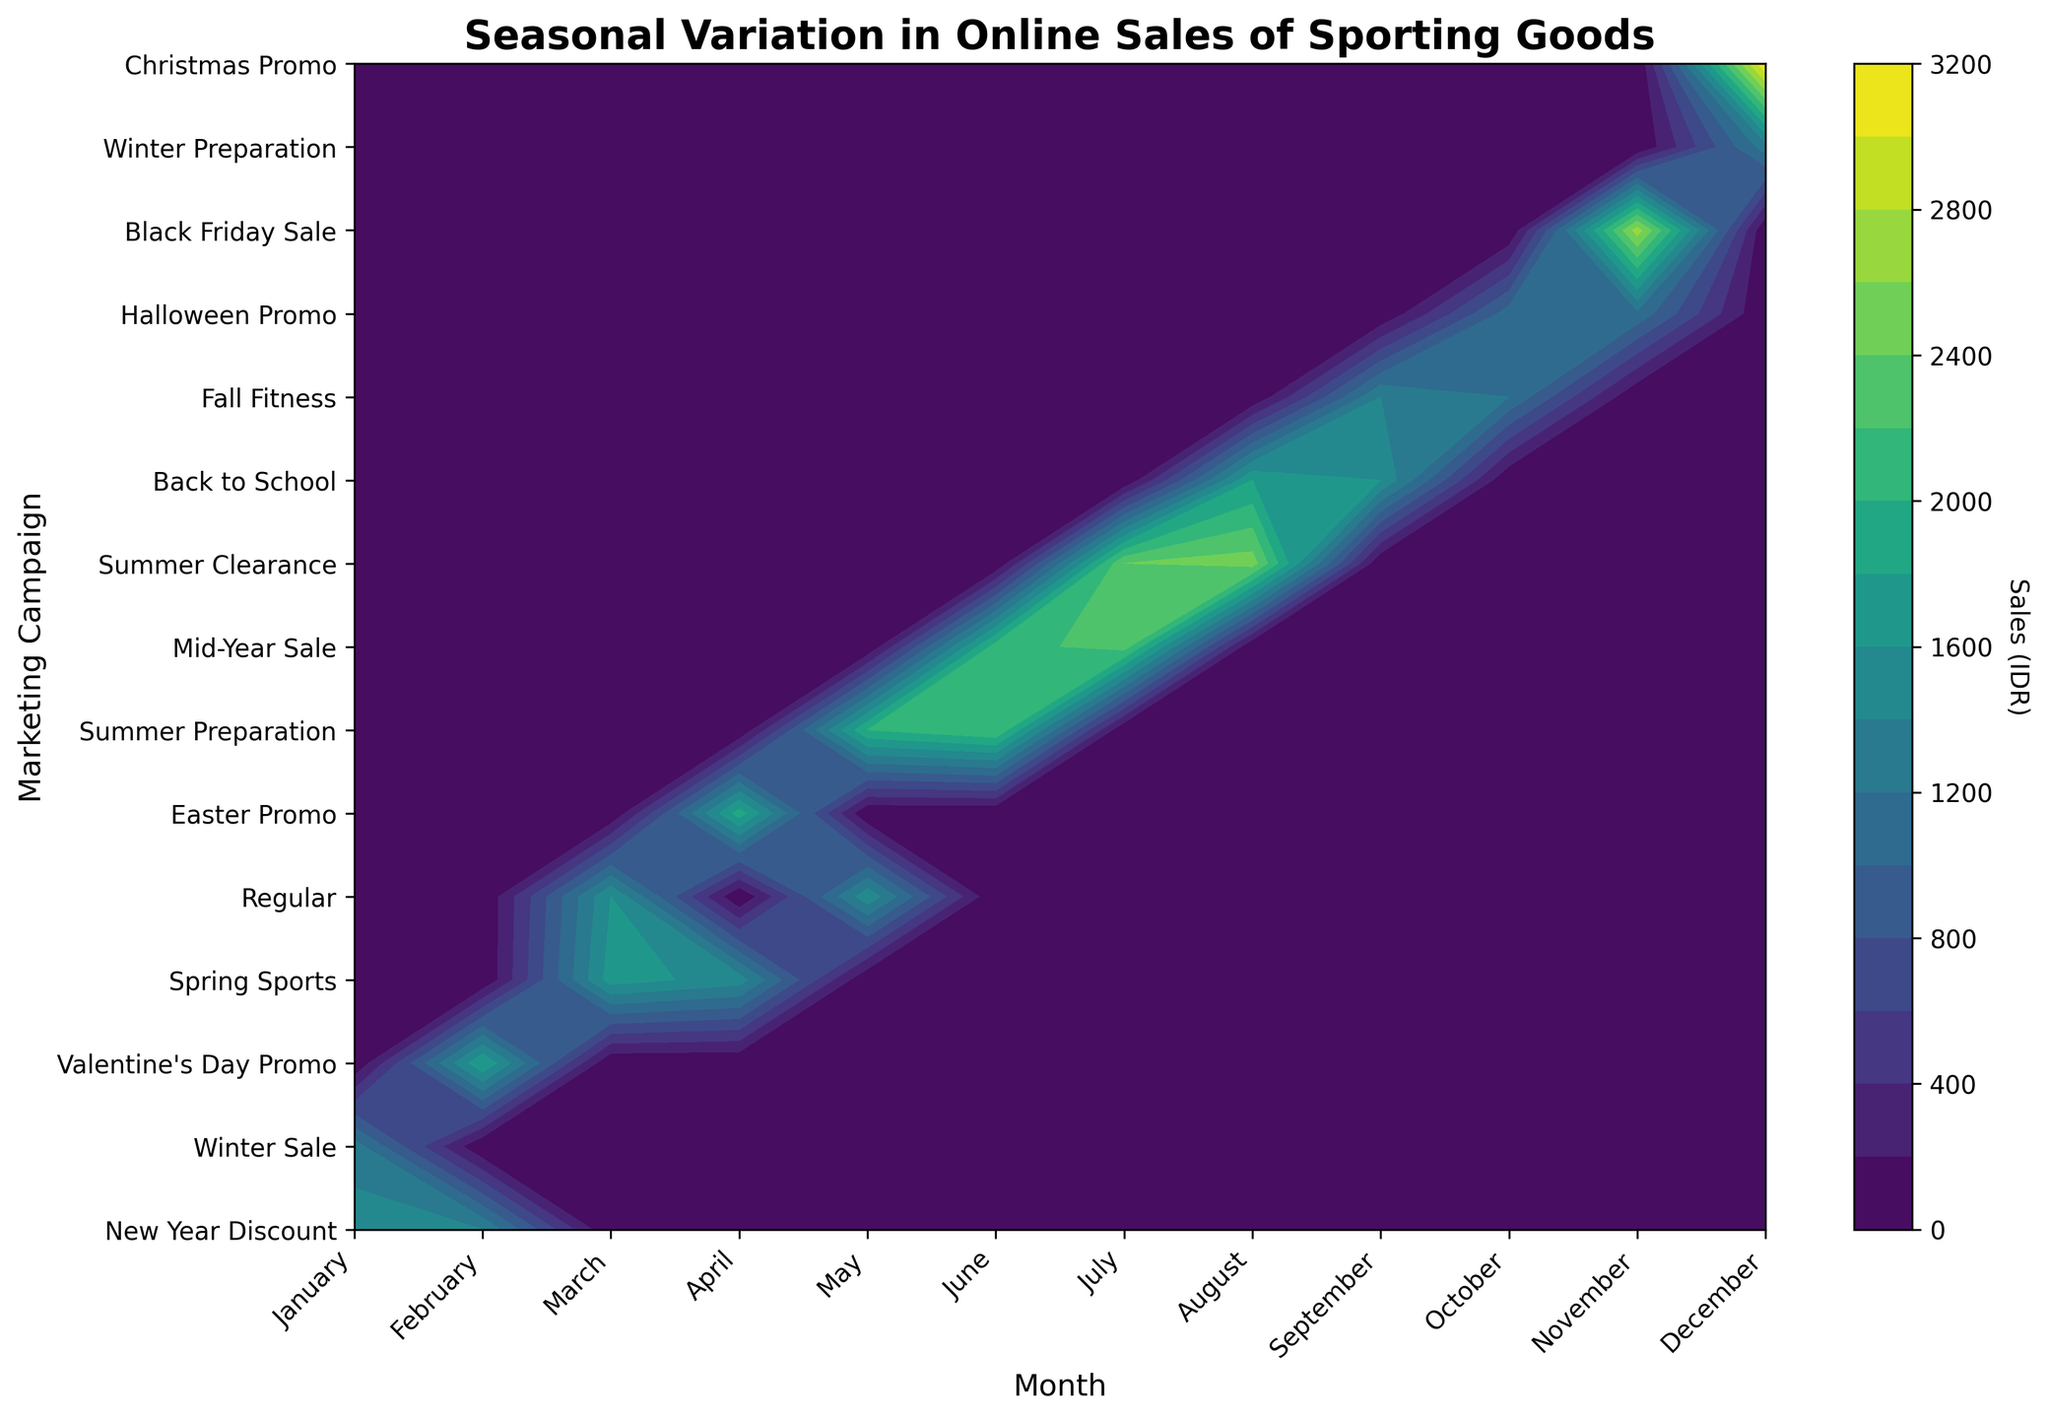What is the title of the figure? The title is always displayed at the top of the figure. In this case, it reads "Seasonal Variation in Online Sales of Sporting Goods".
Answer: Seasonal Variation in Online Sales of Sporting Goods What does the color bar in the figure represent? The color bar represents the sales in Indonesian Rupiah (IDR). It indicates that different shades correspond to different sales values.
Answer: Sales in IDR Which marketing campaign had the highest sales, and in which month did this occur? By examining the contour plot, the darkest shade (highest sales) corresponds to the Christmas Promo in December.
Answer: Christmas Promo in December How do Halloween Promo sales compare between October and November? The sales in October for Halloween Promo are close to 1100, while in November, they are slightly higher, near 1150.
Answer: Higher in November Which month showed the highest variation in sales across different campaigns? By analyzing the density and range of colors within each month column, November shows the highest variation with sales ranging from around 1150 to 2700.
Answer: November Can you identify a period with consistent high sales across multiple campaigns? Look for consecutive months with high sales across different campaigns. The period of June through August shows generally high sales across campaigns like Mid-Year Sale and Summer Clearance.
Answer: June through August What is the sales value for the New Year Discount campaign in January? Locate the intersection of January and New Year Discount and read the color bar for the sales value, which is around 1500.
Answer: 1500 Which month had the lowest sales for the Spring Sports campaign? Compare the shades of the Spring Sports campaign across March and April. It is lighter in April, indicating lower sales.
Answer: April How do the sales in the Mid-Year Sale campaign in June compare to July? The darkest shades for Mid-Year Sale in both months show sales, with July being slightly darker indicating higher sales.
Answer: Higher in July Is there a clear peak in sales during any particular campaign? From the figure, the peak is most noticeable for the Christmas Promo in December with the highest sales value.
Answer: Christmas Promo 